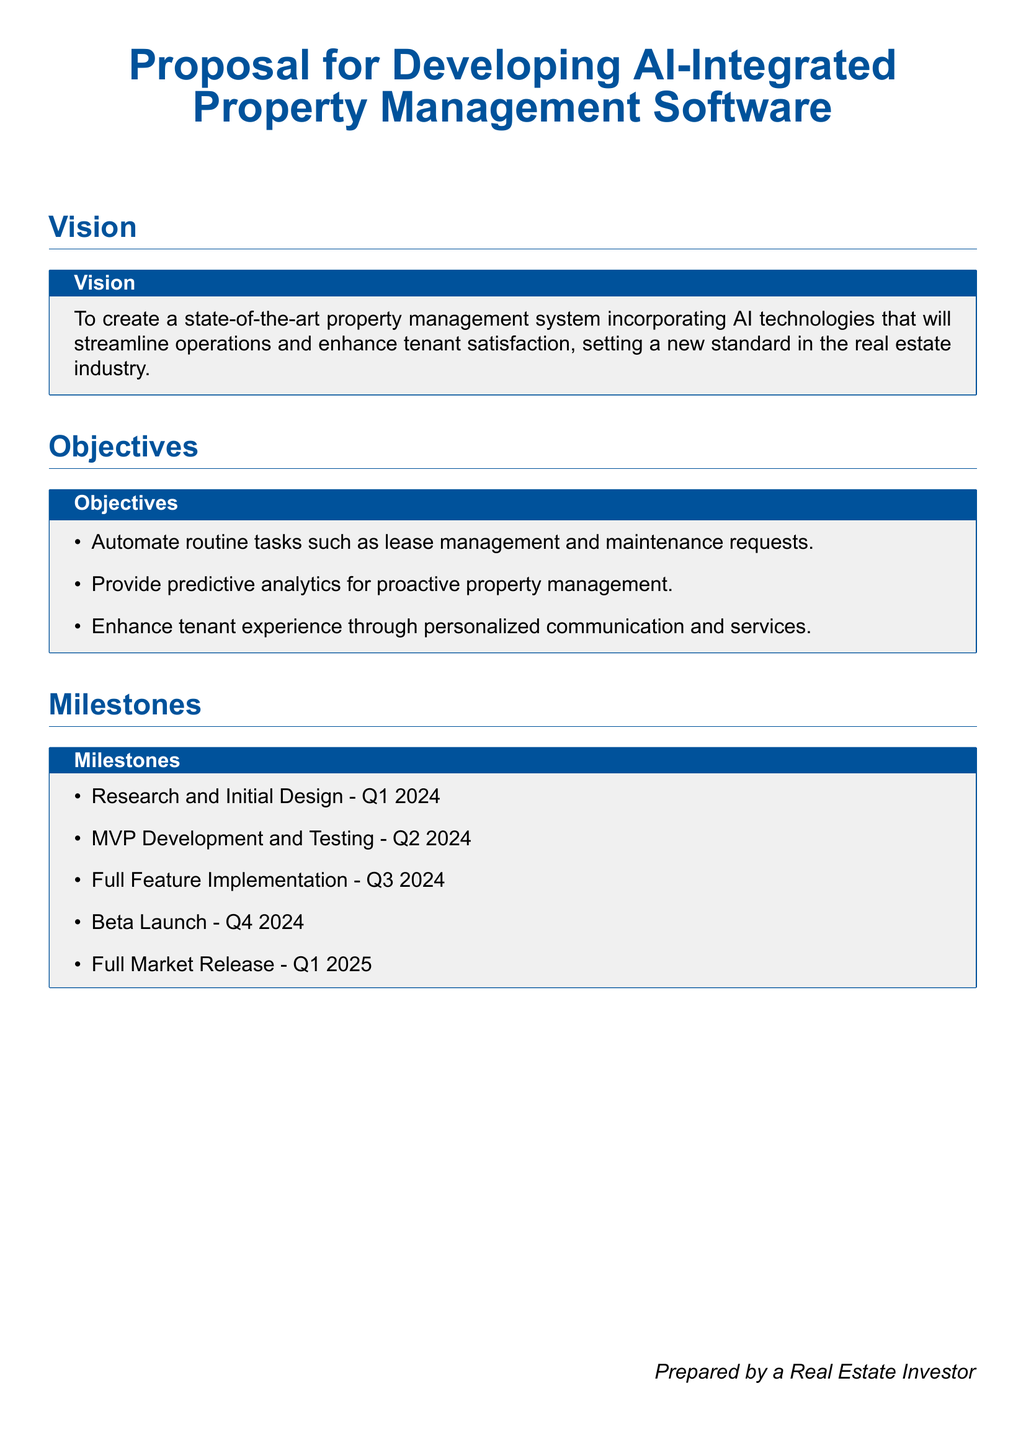what is the title of the proposal? The title of the proposal is presented at the beginning of the document.
Answer: Proposal for Developing AI-Integrated Property Management Software what is the vision of the proposal? The vision outlines the intended goal of the software being developed.
Answer: To create a state-of-the-art property management system what are the first two objectives listed in the document? The objectives specify the key goals of the proposal's development efforts.
Answer: Automate routine tasks, Provide predictive analytics what is the timeline for the MVP Development and Testing? The timeline details the phases for development within specific quarters.
Answer: Q2 2024 how many milestones are outlined in the proposal? The proposal lists specific milestones related to the project timeline.
Answer: Five what is the planned date for the Full Market Release? The Full Market Release is a key milestone that is explicitly mentioned.
Answer: Q1 2025 which quarter is designated for Research and Initial Design? The quarter indicates the starting phase of the project development.
Answer: Q1 2024 what type of technology does the proposal incorporate? The focus of the proposal is on a specific technology area in property management.
Answer: AI technologies what is the intended outcome for tenant experience? This answer summarizes the aim for tenant interactions with the software.
Answer: Enhance tenant experience through personalized communication and services 